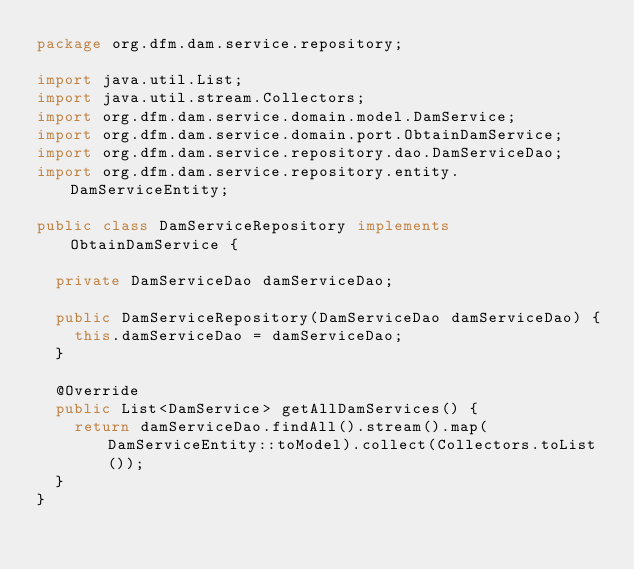Convert code to text. <code><loc_0><loc_0><loc_500><loc_500><_Java_>package org.dfm.dam.service.repository;

import java.util.List;
import java.util.stream.Collectors;
import org.dfm.dam.service.domain.model.DamService;
import org.dfm.dam.service.domain.port.ObtainDamService;
import org.dfm.dam.service.repository.dao.DamServiceDao;
import org.dfm.dam.service.repository.entity.DamServiceEntity;

public class DamServiceRepository implements ObtainDamService {

  private DamServiceDao damServiceDao;

  public DamServiceRepository(DamServiceDao damServiceDao) {
    this.damServiceDao = damServiceDao;
  }

  @Override
  public List<DamService> getAllDamServices() {
    return damServiceDao.findAll().stream().map(DamServiceEntity::toModel).collect(Collectors.toList());
  }
}
</code> 